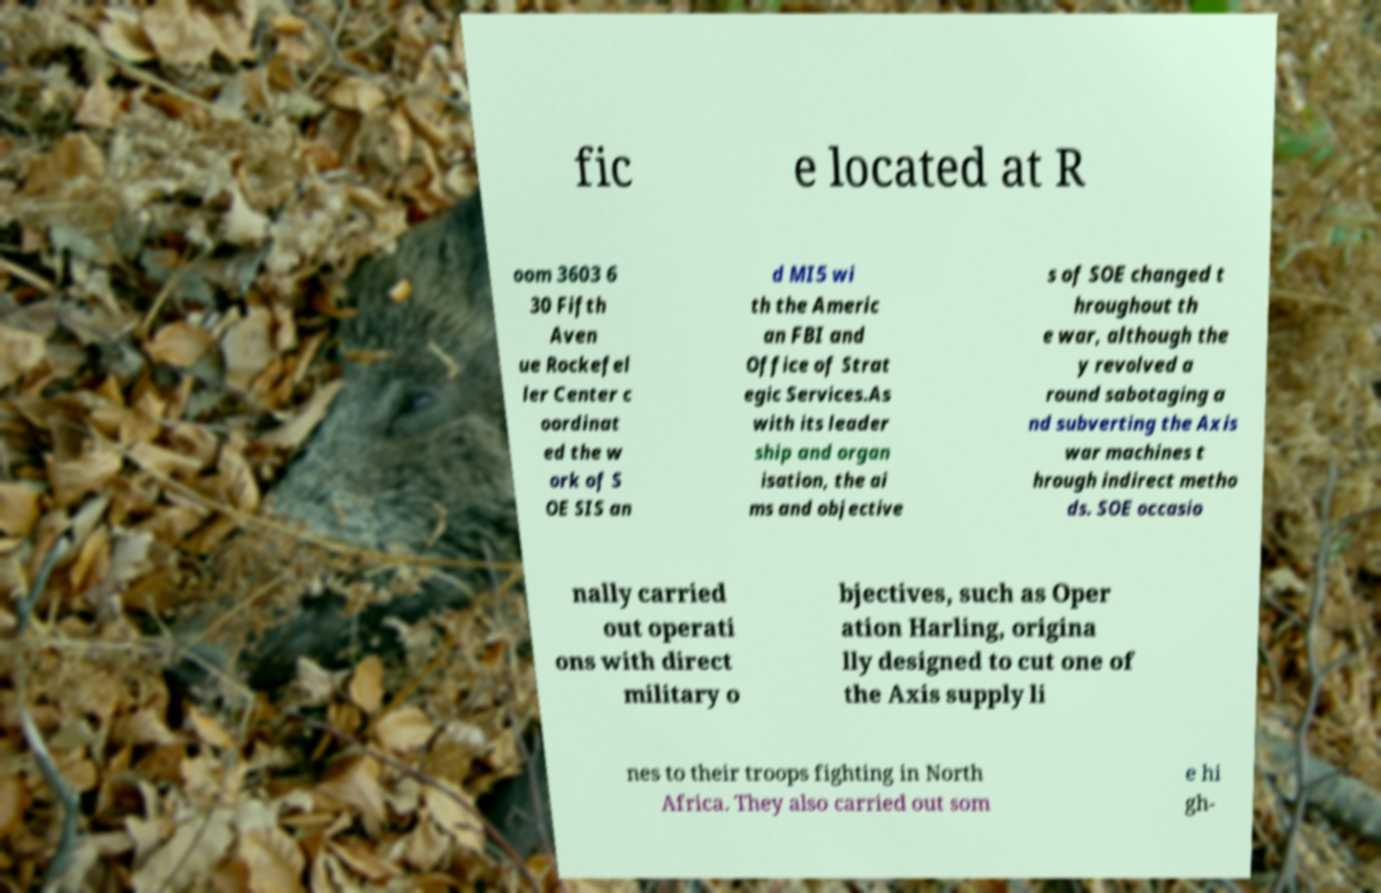Could you extract and type out the text from this image? fic e located at R oom 3603 6 30 Fifth Aven ue Rockefel ler Center c oordinat ed the w ork of S OE SIS an d MI5 wi th the Americ an FBI and Office of Strat egic Services.As with its leader ship and organ isation, the ai ms and objective s of SOE changed t hroughout th e war, although the y revolved a round sabotaging a nd subverting the Axis war machines t hrough indirect metho ds. SOE occasio nally carried out operati ons with direct military o bjectives, such as Oper ation Harling, origina lly designed to cut one of the Axis supply li nes to their troops fighting in North Africa. They also carried out som e hi gh- 